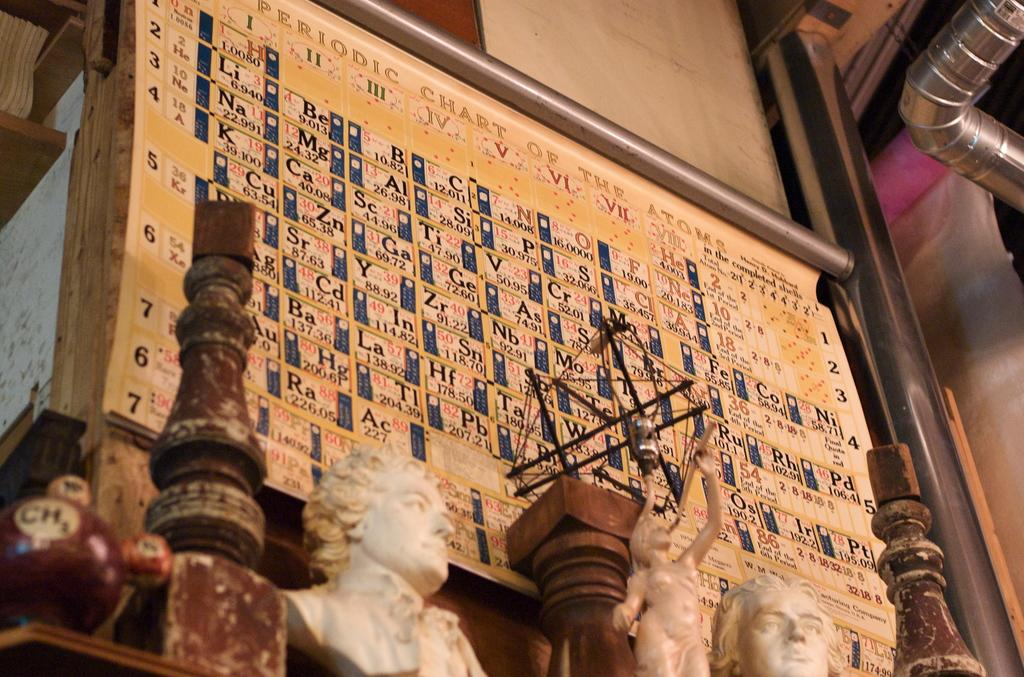What is on the wall in the image? There is a chart on the wall in the image. What type of decorative items can be seen in the image? There are statues in the image. What is blocking the view of the chart in the image? There are other objects in front of the chart in the image. What type of material is used for the pipes in the image? There are iron pipes in the image. Can you see the ghost in the image? There is no ghost present in the image. What is the son doing in the image? There is no son present in the image. 